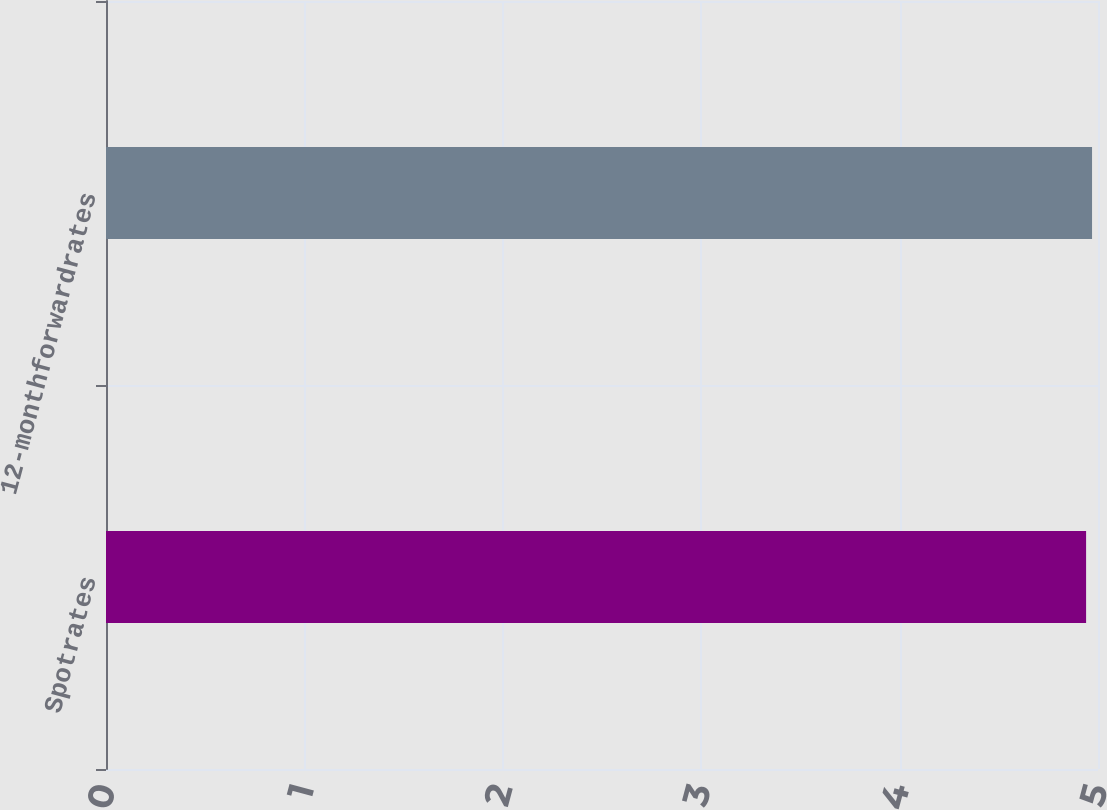<chart> <loc_0><loc_0><loc_500><loc_500><bar_chart><fcel>Spotrates<fcel>12-monthforwardrates<nl><fcel>4.94<fcel>4.97<nl></chart> 